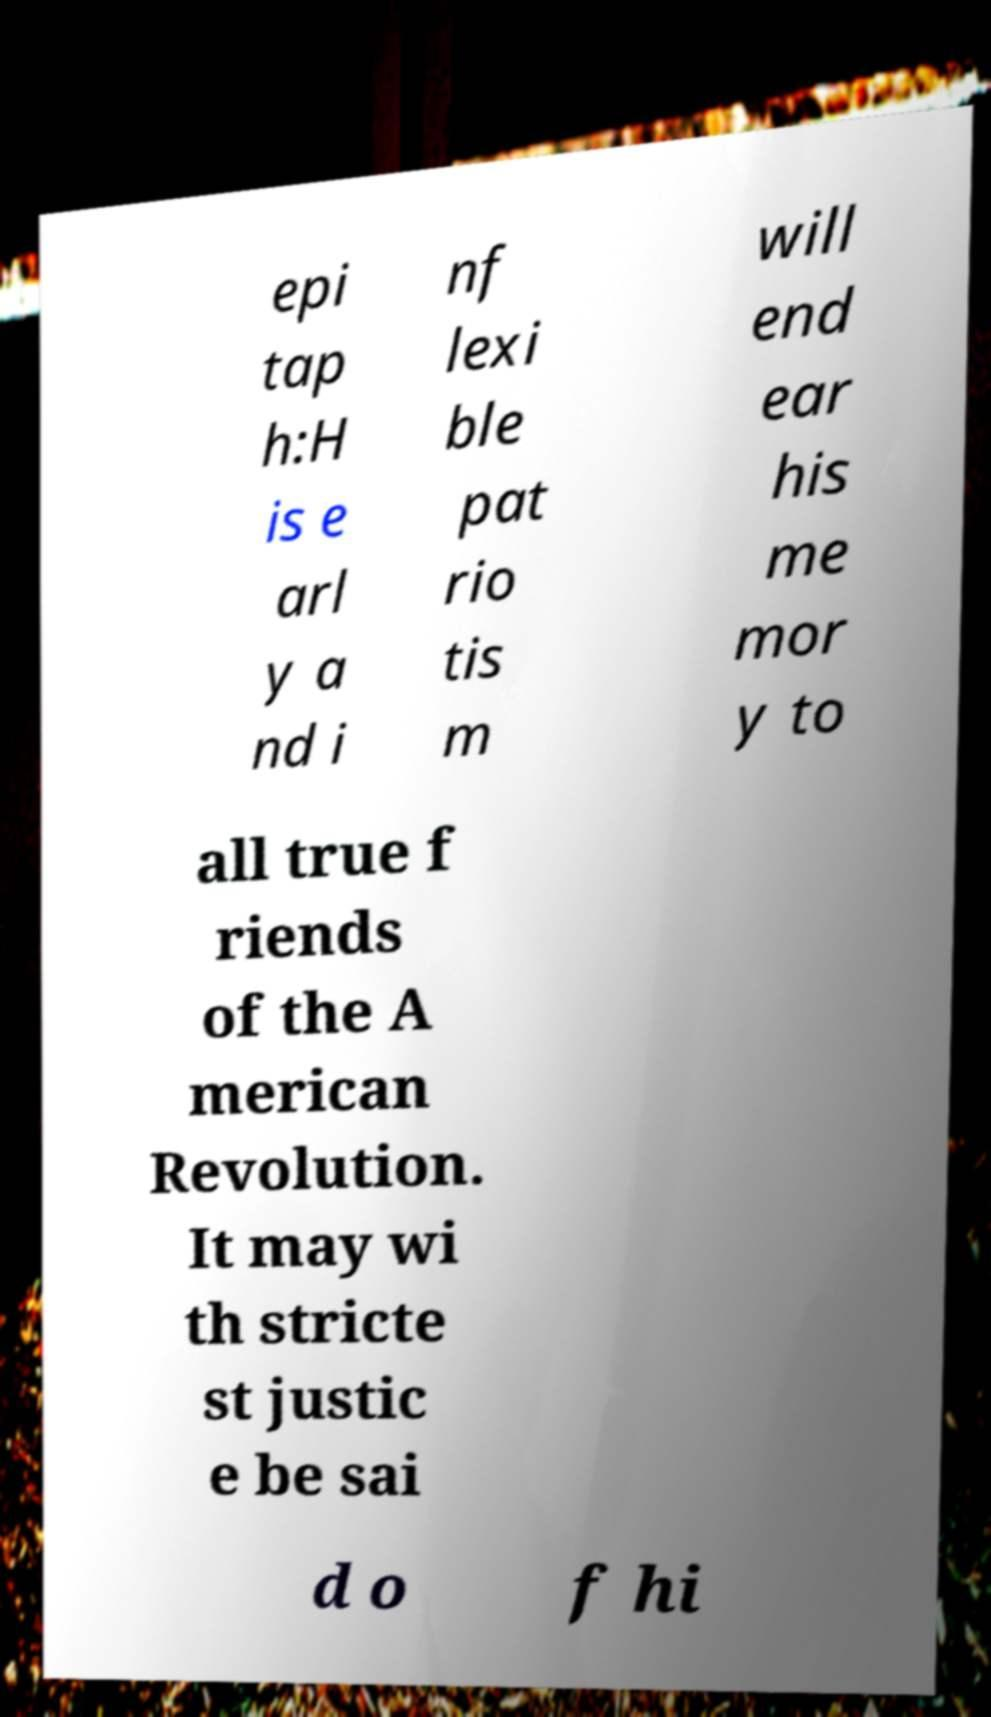Can you read and provide the text displayed in the image?This photo seems to have some interesting text. Can you extract and type it out for me? epi tap h:H is e arl y a nd i nf lexi ble pat rio tis m will end ear his me mor y to all true f riends of the A merican Revolution. It may wi th stricte st justic e be sai d o f hi 